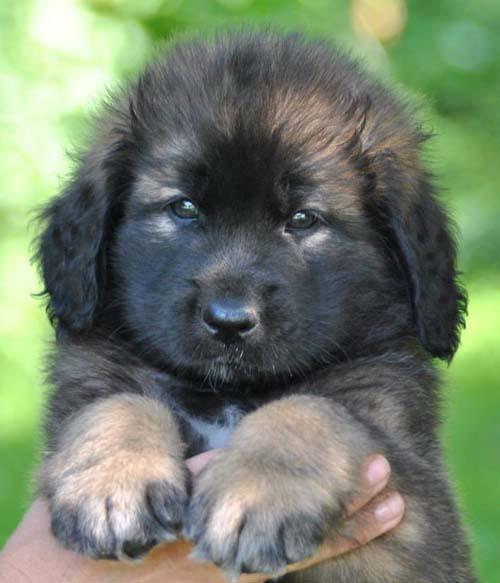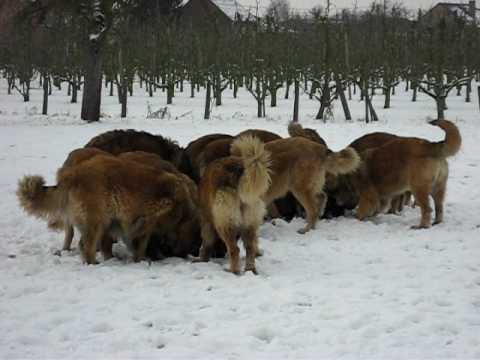The first image is the image on the left, the second image is the image on the right. For the images shown, is this caption "The left photo depicts a puppy with its front paws propped up on something." true? Answer yes or no. Yes. The first image is the image on the left, the second image is the image on the right. Evaluate the accuracy of this statement regarding the images: "A puppy sits upright with its front paws hanging over something else.". Is it true? Answer yes or no. Yes. 